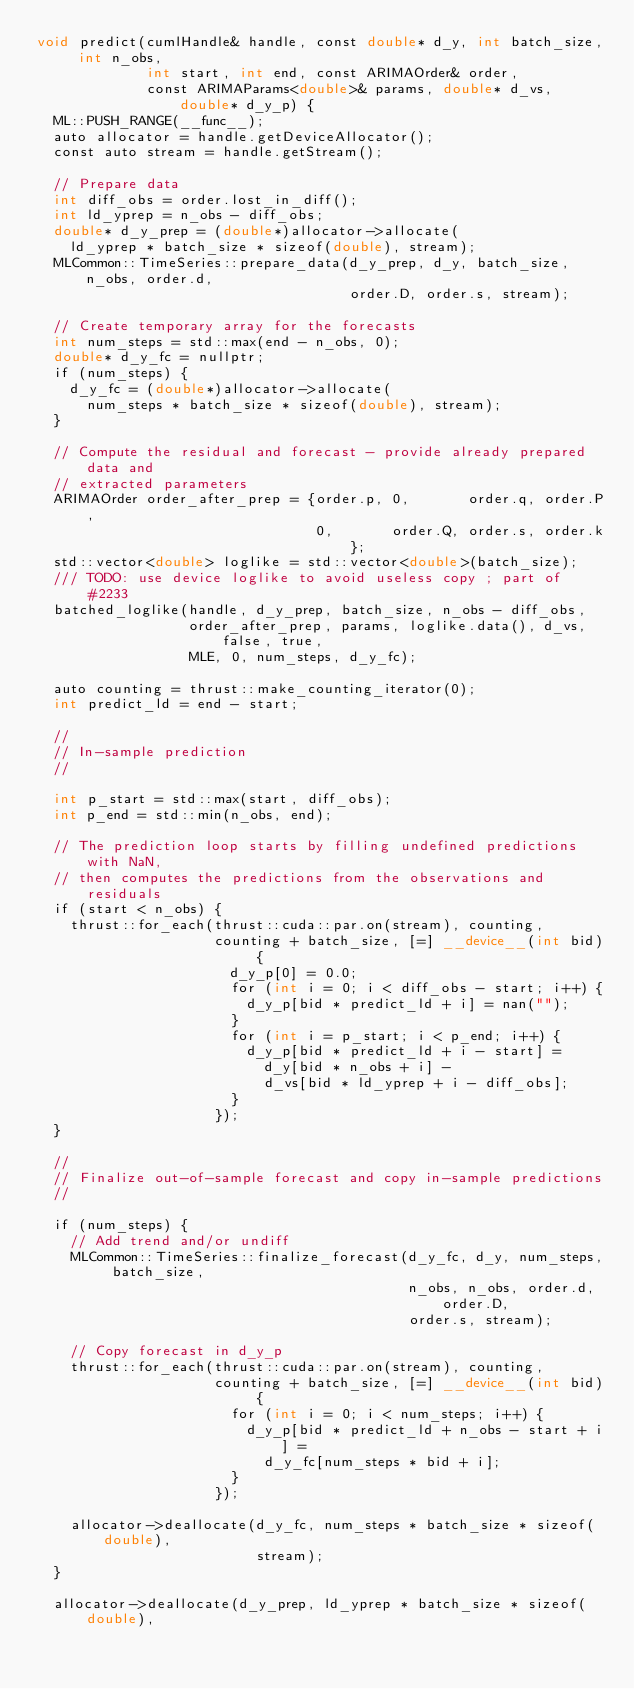<code> <loc_0><loc_0><loc_500><loc_500><_Cuda_>void predict(cumlHandle& handle, const double* d_y, int batch_size, int n_obs,
             int start, int end, const ARIMAOrder& order,
             const ARIMAParams<double>& params, double* d_vs, double* d_y_p) {
  ML::PUSH_RANGE(__func__);
  auto allocator = handle.getDeviceAllocator();
  const auto stream = handle.getStream();

  // Prepare data
  int diff_obs = order.lost_in_diff();
  int ld_yprep = n_obs - diff_obs;
  double* d_y_prep = (double*)allocator->allocate(
    ld_yprep * batch_size * sizeof(double), stream);
  MLCommon::TimeSeries::prepare_data(d_y_prep, d_y, batch_size, n_obs, order.d,
                                     order.D, order.s, stream);

  // Create temporary array for the forecasts
  int num_steps = std::max(end - n_obs, 0);
  double* d_y_fc = nullptr;
  if (num_steps) {
    d_y_fc = (double*)allocator->allocate(
      num_steps * batch_size * sizeof(double), stream);
  }

  // Compute the residual and forecast - provide already prepared data and
  // extracted parameters
  ARIMAOrder order_after_prep = {order.p, 0,       order.q, order.P,
                                 0,       order.Q, order.s, order.k};
  std::vector<double> loglike = std::vector<double>(batch_size);
  /// TODO: use device loglike to avoid useless copy ; part of #2233
  batched_loglike(handle, d_y_prep, batch_size, n_obs - diff_obs,
                  order_after_prep, params, loglike.data(), d_vs, false, true,
                  MLE, 0, num_steps, d_y_fc);

  auto counting = thrust::make_counting_iterator(0);
  int predict_ld = end - start;

  //
  // In-sample prediction
  //

  int p_start = std::max(start, diff_obs);
  int p_end = std::min(n_obs, end);

  // The prediction loop starts by filling undefined predictions with NaN,
  // then computes the predictions from the observations and residuals
  if (start < n_obs) {
    thrust::for_each(thrust::cuda::par.on(stream), counting,
                     counting + batch_size, [=] __device__(int bid) {
                       d_y_p[0] = 0.0;
                       for (int i = 0; i < diff_obs - start; i++) {
                         d_y_p[bid * predict_ld + i] = nan("");
                       }
                       for (int i = p_start; i < p_end; i++) {
                         d_y_p[bid * predict_ld + i - start] =
                           d_y[bid * n_obs + i] -
                           d_vs[bid * ld_yprep + i - diff_obs];
                       }
                     });
  }

  //
  // Finalize out-of-sample forecast and copy in-sample predictions
  //

  if (num_steps) {
    // Add trend and/or undiff
    MLCommon::TimeSeries::finalize_forecast(d_y_fc, d_y, num_steps, batch_size,
                                            n_obs, n_obs, order.d, order.D,
                                            order.s, stream);

    // Copy forecast in d_y_p
    thrust::for_each(thrust::cuda::par.on(stream), counting,
                     counting + batch_size, [=] __device__(int bid) {
                       for (int i = 0; i < num_steps; i++) {
                         d_y_p[bid * predict_ld + n_obs - start + i] =
                           d_y_fc[num_steps * bid + i];
                       }
                     });

    allocator->deallocate(d_y_fc, num_steps * batch_size * sizeof(double),
                          stream);
  }

  allocator->deallocate(d_y_prep, ld_yprep * batch_size * sizeof(double),</code> 